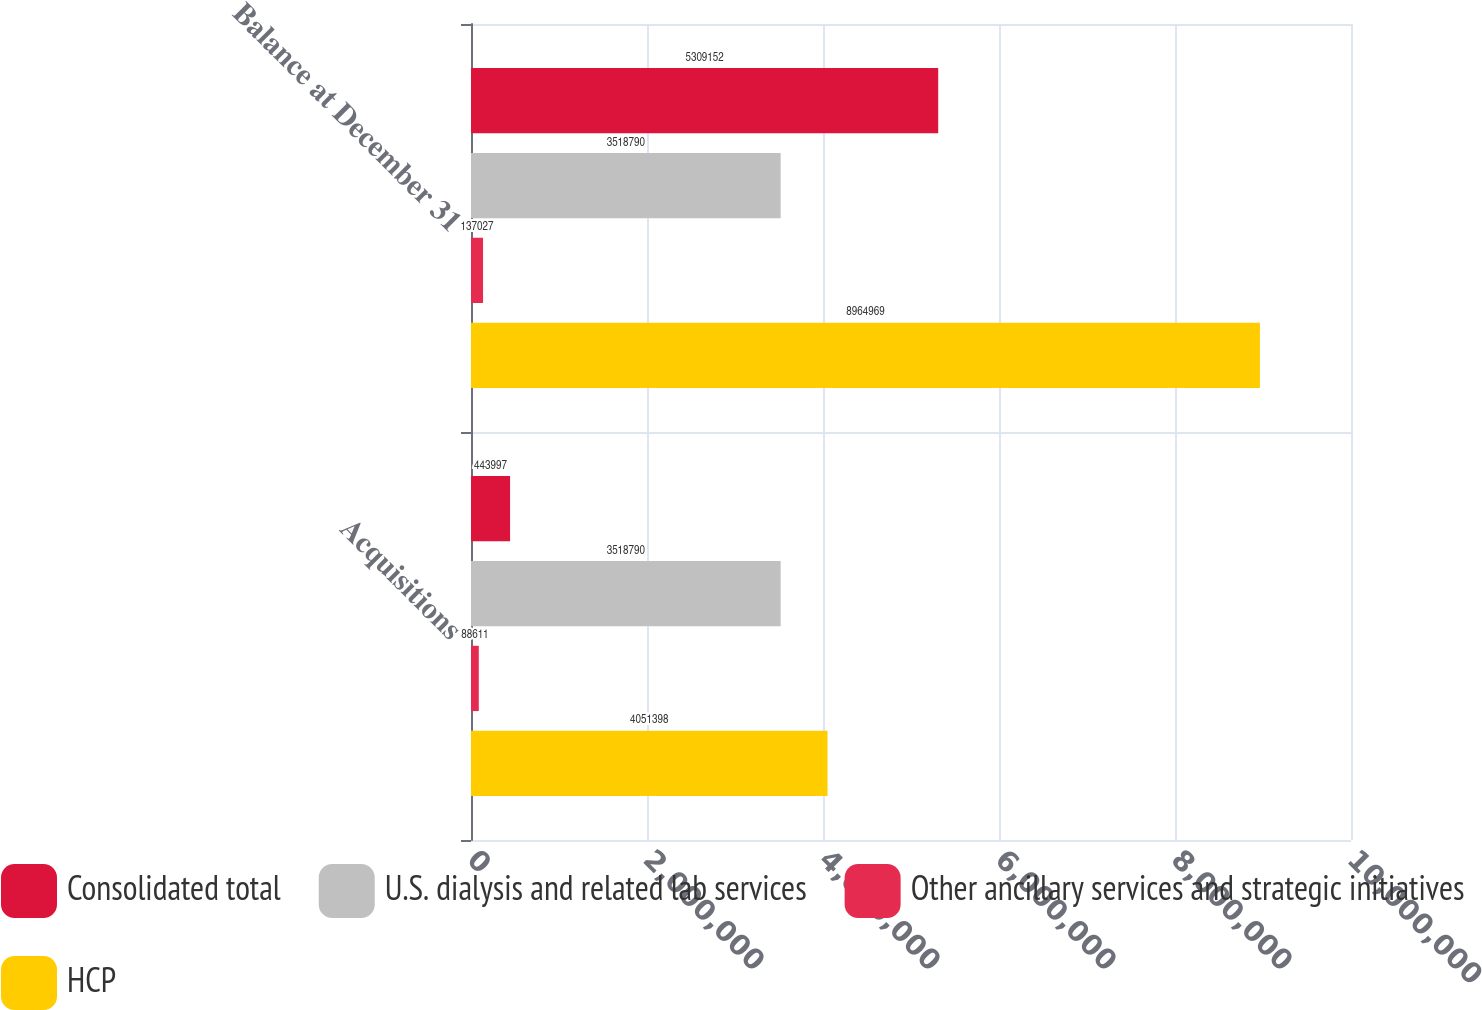Convert chart. <chart><loc_0><loc_0><loc_500><loc_500><stacked_bar_chart><ecel><fcel>Acquisitions<fcel>Balance at December 31<nl><fcel>Consolidated total<fcel>443997<fcel>5.30915e+06<nl><fcel>U.S. dialysis and related lab services<fcel>3.51879e+06<fcel>3.51879e+06<nl><fcel>Other ancillary services and strategic initiatives<fcel>88611<fcel>137027<nl><fcel>HCP<fcel>4.0514e+06<fcel>8.96497e+06<nl></chart> 